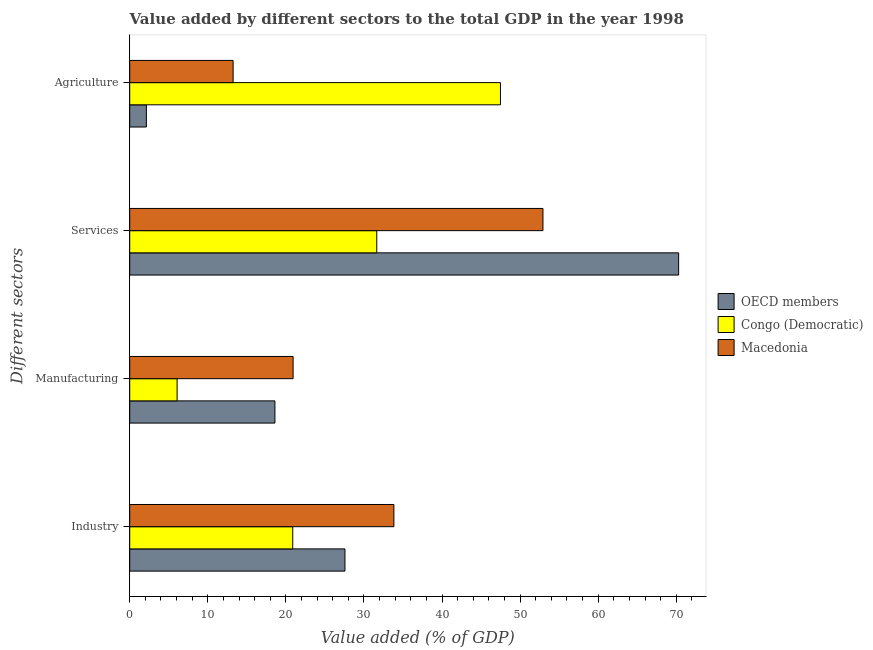How many different coloured bars are there?
Your answer should be compact. 3. How many groups of bars are there?
Provide a succinct answer. 4. What is the label of the 2nd group of bars from the top?
Offer a very short reply. Services. What is the value added by industrial sector in Macedonia?
Your answer should be compact. 33.83. Across all countries, what is the maximum value added by agricultural sector?
Your answer should be very brief. 47.48. Across all countries, what is the minimum value added by industrial sector?
Your answer should be compact. 20.88. In which country was the value added by agricultural sector minimum?
Offer a terse response. OECD members. What is the total value added by industrial sector in the graph?
Keep it short and to the point. 82.28. What is the difference between the value added by services sector in Macedonia and that in OECD members?
Offer a very short reply. -17.38. What is the difference between the value added by agricultural sector in Macedonia and the value added by manufacturing sector in OECD members?
Your answer should be compact. -5.35. What is the average value added by industrial sector per country?
Your answer should be very brief. 27.43. What is the difference between the value added by manufacturing sector and value added by agricultural sector in Congo (Democratic)?
Your response must be concise. -41.41. What is the ratio of the value added by services sector in OECD members to that in Congo (Democratic)?
Your response must be concise. 2.22. Is the difference between the value added by agricultural sector in OECD members and Macedonia greater than the difference between the value added by industrial sector in OECD members and Macedonia?
Provide a short and direct response. No. What is the difference between the highest and the second highest value added by services sector?
Your response must be concise. 17.38. What is the difference between the highest and the lowest value added by agricultural sector?
Your response must be concise. 45.35. What does the 3rd bar from the bottom in Industry represents?
Provide a succinct answer. Macedonia. Are all the bars in the graph horizontal?
Give a very brief answer. Yes. What is the difference between two consecutive major ticks on the X-axis?
Your response must be concise. 10. Does the graph contain any zero values?
Your answer should be very brief. No. Where does the legend appear in the graph?
Provide a succinct answer. Center right. How are the legend labels stacked?
Provide a short and direct response. Vertical. What is the title of the graph?
Offer a terse response. Value added by different sectors to the total GDP in the year 1998. What is the label or title of the X-axis?
Your answer should be compact. Value added (% of GDP). What is the label or title of the Y-axis?
Offer a terse response. Different sectors. What is the Value added (% of GDP) of OECD members in Industry?
Provide a succinct answer. 27.56. What is the Value added (% of GDP) of Congo (Democratic) in Industry?
Your answer should be compact. 20.88. What is the Value added (% of GDP) in Macedonia in Industry?
Your answer should be very brief. 33.83. What is the Value added (% of GDP) in OECD members in Manufacturing?
Give a very brief answer. 18.6. What is the Value added (% of GDP) in Congo (Democratic) in Manufacturing?
Provide a short and direct response. 6.07. What is the Value added (% of GDP) of Macedonia in Manufacturing?
Ensure brevity in your answer.  20.92. What is the Value added (% of GDP) of OECD members in Services?
Provide a succinct answer. 70.3. What is the Value added (% of GDP) of Congo (Democratic) in Services?
Your response must be concise. 31.64. What is the Value added (% of GDP) of Macedonia in Services?
Offer a terse response. 52.92. What is the Value added (% of GDP) of OECD members in Agriculture?
Make the answer very short. 2.13. What is the Value added (% of GDP) in Congo (Democratic) in Agriculture?
Your answer should be very brief. 47.48. What is the Value added (% of GDP) in Macedonia in Agriculture?
Your answer should be very brief. 13.24. Across all Different sectors, what is the maximum Value added (% of GDP) in OECD members?
Offer a very short reply. 70.3. Across all Different sectors, what is the maximum Value added (% of GDP) of Congo (Democratic)?
Your answer should be very brief. 47.48. Across all Different sectors, what is the maximum Value added (% of GDP) in Macedonia?
Provide a short and direct response. 52.92. Across all Different sectors, what is the minimum Value added (% of GDP) in OECD members?
Offer a very short reply. 2.13. Across all Different sectors, what is the minimum Value added (% of GDP) in Congo (Democratic)?
Ensure brevity in your answer.  6.07. Across all Different sectors, what is the minimum Value added (% of GDP) of Macedonia?
Your answer should be compact. 13.24. What is the total Value added (% of GDP) of OECD members in the graph?
Offer a very short reply. 118.6. What is the total Value added (% of GDP) in Congo (Democratic) in the graph?
Your response must be concise. 106.07. What is the total Value added (% of GDP) in Macedonia in the graph?
Provide a short and direct response. 120.92. What is the difference between the Value added (% of GDP) in OECD members in Industry and that in Manufacturing?
Give a very brief answer. 8.97. What is the difference between the Value added (% of GDP) of Congo (Democratic) in Industry and that in Manufacturing?
Ensure brevity in your answer.  14.81. What is the difference between the Value added (% of GDP) of Macedonia in Industry and that in Manufacturing?
Your answer should be very brief. 12.91. What is the difference between the Value added (% of GDP) of OECD members in Industry and that in Services?
Offer a terse response. -42.74. What is the difference between the Value added (% of GDP) of Congo (Democratic) in Industry and that in Services?
Ensure brevity in your answer.  -10.76. What is the difference between the Value added (% of GDP) of Macedonia in Industry and that in Services?
Provide a short and direct response. -19.09. What is the difference between the Value added (% of GDP) in OECD members in Industry and that in Agriculture?
Your response must be concise. 25.43. What is the difference between the Value added (% of GDP) of Congo (Democratic) in Industry and that in Agriculture?
Ensure brevity in your answer.  -26.6. What is the difference between the Value added (% of GDP) of Macedonia in Industry and that in Agriculture?
Keep it short and to the point. 20.59. What is the difference between the Value added (% of GDP) in OECD members in Manufacturing and that in Services?
Ensure brevity in your answer.  -51.71. What is the difference between the Value added (% of GDP) in Congo (Democratic) in Manufacturing and that in Services?
Ensure brevity in your answer.  -25.57. What is the difference between the Value added (% of GDP) of Macedonia in Manufacturing and that in Services?
Keep it short and to the point. -32. What is the difference between the Value added (% of GDP) of OECD members in Manufacturing and that in Agriculture?
Offer a terse response. 16.46. What is the difference between the Value added (% of GDP) in Congo (Democratic) in Manufacturing and that in Agriculture?
Ensure brevity in your answer.  -41.41. What is the difference between the Value added (% of GDP) in Macedonia in Manufacturing and that in Agriculture?
Your answer should be compact. 7.68. What is the difference between the Value added (% of GDP) in OECD members in Services and that in Agriculture?
Your answer should be very brief. 68.17. What is the difference between the Value added (% of GDP) of Congo (Democratic) in Services and that in Agriculture?
Ensure brevity in your answer.  -15.84. What is the difference between the Value added (% of GDP) in Macedonia in Services and that in Agriculture?
Ensure brevity in your answer.  39.68. What is the difference between the Value added (% of GDP) of OECD members in Industry and the Value added (% of GDP) of Congo (Democratic) in Manufacturing?
Give a very brief answer. 21.5. What is the difference between the Value added (% of GDP) of OECD members in Industry and the Value added (% of GDP) of Macedonia in Manufacturing?
Ensure brevity in your answer.  6.64. What is the difference between the Value added (% of GDP) of Congo (Democratic) in Industry and the Value added (% of GDP) of Macedonia in Manufacturing?
Ensure brevity in your answer.  -0.05. What is the difference between the Value added (% of GDP) in OECD members in Industry and the Value added (% of GDP) in Congo (Democratic) in Services?
Provide a short and direct response. -4.08. What is the difference between the Value added (% of GDP) of OECD members in Industry and the Value added (% of GDP) of Macedonia in Services?
Keep it short and to the point. -25.36. What is the difference between the Value added (% of GDP) of Congo (Democratic) in Industry and the Value added (% of GDP) of Macedonia in Services?
Ensure brevity in your answer.  -32.05. What is the difference between the Value added (% of GDP) in OECD members in Industry and the Value added (% of GDP) in Congo (Democratic) in Agriculture?
Your answer should be very brief. -19.92. What is the difference between the Value added (% of GDP) of OECD members in Industry and the Value added (% of GDP) of Macedonia in Agriculture?
Your answer should be very brief. 14.32. What is the difference between the Value added (% of GDP) in Congo (Democratic) in Industry and the Value added (% of GDP) in Macedonia in Agriculture?
Your answer should be compact. 7.64. What is the difference between the Value added (% of GDP) of OECD members in Manufacturing and the Value added (% of GDP) of Congo (Democratic) in Services?
Keep it short and to the point. -13.05. What is the difference between the Value added (% of GDP) in OECD members in Manufacturing and the Value added (% of GDP) in Macedonia in Services?
Ensure brevity in your answer.  -34.33. What is the difference between the Value added (% of GDP) in Congo (Democratic) in Manufacturing and the Value added (% of GDP) in Macedonia in Services?
Provide a succinct answer. -46.86. What is the difference between the Value added (% of GDP) in OECD members in Manufacturing and the Value added (% of GDP) in Congo (Democratic) in Agriculture?
Ensure brevity in your answer.  -28.89. What is the difference between the Value added (% of GDP) in OECD members in Manufacturing and the Value added (% of GDP) in Macedonia in Agriculture?
Your answer should be compact. 5.35. What is the difference between the Value added (% of GDP) of Congo (Democratic) in Manufacturing and the Value added (% of GDP) of Macedonia in Agriculture?
Your answer should be compact. -7.17. What is the difference between the Value added (% of GDP) in OECD members in Services and the Value added (% of GDP) in Congo (Democratic) in Agriculture?
Ensure brevity in your answer.  22.82. What is the difference between the Value added (% of GDP) of OECD members in Services and the Value added (% of GDP) of Macedonia in Agriculture?
Offer a terse response. 57.06. What is the difference between the Value added (% of GDP) of Congo (Democratic) in Services and the Value added (% of GDP) of Macedonia in Agriculture?
Provide a succinct answer. 18.4. What is the average Value added (% of GDP) of OECD members per Different sectors?
Your answer should be compact. 29.65. What is the average Value added (% of GDP) in Congo (Democratic) per Different sectors?
Your answer should be compact. 26.52. What is the average Value added (% of GDP) of Macedonia per Different sectors?
Provide a short and direct response. 30.23. What is the difference between the Value added (% of GDP) in OECD members and Value added (% of GDP) in Congo (Democratic) in Industry?
Ensure brevity in your answer.  6.69. What is the difference between the Value added (% of GDP) of OECD members and Value added (% of GDP) of Macedonia in Industry?
Make the answer very short. -6.27. What is the difference between the Value added (% of GDP) in Congo (Democratic) and Value added (% of GDP) in Macedonia in Industry?
Give a very brief answer. -12.96. What is the difference between the Value added (% of GDP) in OECD members and Value added (% of GDP) in Congo (Democratic) in Manufacturing?
Make the answer very short. 12.53. What is the difference between the Value added (% of GDP) of OECD members and Value added (% of GDP) of Macedonia in Manufacturing?
Your answer should be compact. -2.33. What is the difference between the Value added (% of GDP) of Congo (Democratic) and Value added (% of GDP) of Macedonia in Manufacturing?
Offer a terse response. -14.86. What is the difference between the Value added (% of GDP) of OECD members and Value added (% of GDP) of Congo (Democratic) in Services?
Give a very brief answer. 38.66. What is the difference between the Value added (% of GDP) of OECD members and Value added (% of GDP) of Macedonia in Services?
Your answer should be compact. 17.38. What is the difference between the Value added (% of GDP) in Congo (Democratic) and Value added (% of GDP) in Macedonia in Services?
Make the answer very short. -21.28. What is the difference between the Value added (% of GDP) in OECD members and Value added (% of GDP) in Congo (Democratic) in Agriculture?
Your answer should be very brief. -45.35. What is the difference between the Value added (% of GDP) in OECD members and Value added (% of GDP) in Macedonia in Agriculture?
Give a very brief answer. -11.11. What is the difference between the Value added (% of GDP) of Congo (Democratic) and Value added (% of GDP) of Macedonia in Agriculture?
Offer a terse response. 34.24. What is the ratio of the Value added (% of GDP) in OECD members in Industry to that in Manufacturing?
Keep it short and to the point. 1.48. What is the ratio of the Value added (% of GDP) of Congo (Democratic) in Industry to that in Manufacturing?
Ensure brevity in your answer.  3.44. What is the ratio of the Value added (% of GDP) in Macedonia in Industry to that in Manufacturing?
Make the answer very short. 1.62. What is the ratio of the Value added (% of GDP) in OECD members in Industry to that in Services?
Give a very brief answer. 0.39. What is the ratio of the Value added (% of GDP) in Congo (Democratic) in Industry to that in Services?
Make the answer very short. 0.66. What is the ratio of the Value added (% of GDP) of Macedonia in Industry to that in Services?
Keep it short and to the point. 0.64. What is the ratio of the Value added (% of GDP) in OECD members in Industry to that in Agriculture?
Your response must be concise. 12.93. What is the ratio of the Value added (% of GDP) in Congo (Democratic) in Industry to that in Agriculture?
Offer a very short reply. 0.44. What is the ratio of the Value added (% of GDP) in Macedonia in Industry to that in Agriculture?
Provide a succinct answer. 2.56. What is the ratio of the Value added (% of GDP) in OECD members in Manufacturing to that in Services?
Your answer should be very brief. 0.26. What is the ratio of the Value added (% of GDP) in Congo (Democratic) in Manufacturing to that in Services?
Offer a very short reply. 0.19. What is the ratio of the Value added (% of GDP) in Macedonia in Manufacturing to that in Services?
Ensure brevity in your answer.  0.4. What is the ratio of the Value added (% of GDP) in OECD members in Manufacturing to that in Agriculture?
Give a very brief answer. 8.72. What is the ratio of the Value added (% of GDP) in Congo (Democratic) in Manufacturing to that in Agriculture?
Your answer should be compact. 0.13. What is the ratio of the Value added (% of GDP) of Macedonia in Manufacturing to that in Agriculture?
Make the answer very short. 1.58. What is the ratio of the Value added (% of GDP) of OECD members in Services to that in Agriculture?
Provide a short and direct response. 32.98. What is the ratio of the Value added (% of GDP) of Congo (Democratic) in Services to that in Agriculture?
Provide a succinct answer. 0.67. What is the ratio of the Value added (% of GDP) in Macedonia in Services to that in Agriculture?
Make the answer very short. 4. What is the difference between the highest and the second highest Value added (% of GDP) of OECD members?
Make the answer very short. 42.74. What is the difference between the highest and the second highest Value added (% of GDP) in Congo (Democratic)?
Provide a succinct answer. 15.84. What is the difference between the highest and the second highest Value added (% of GDP) of Macedonia?
Provide a succinct answer. 19.09. What is the difference between the highest and the lowest Value added (% of GDP) of OECD members?
Offer a terse response. 68.17. What is the difference between the highest and the lowest Value added (% of GDP) in Congo (Democratic)?
Ensure brevity in your answer.  41.41. What is the difference between the highest and the lowest Value added (% of GDP) in Macedonia?
Offer a terse response. 39.68. 